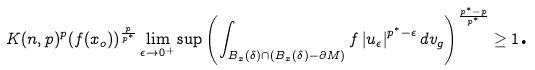Convert formula to latex. <formula><loc_0><loc_0><loc_500><loc_500>K ( n , p ) ^ { p } ( f ( x _ { o } ) ) ^ { \frac { p } { p ^ { \ast } } } \lim _ { \epsilon \rightarrow 0 ^ { + } } \sup \left ( \int _ { B _ { x } ( \delta ) \cap ( B _ { x } ( \delta ) - \partial M ) } f \left | u _ { \epsilon } \right | ^ { p ^ { \ast } - \epsilon } d v _ { g } \right ) ^ { \frac { p ^ { \ast } - p } { p ^ { \ast } } } \geq 1 \text {.}</formula> 